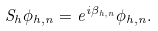<formula> <loc_0><loc_0><loc_500><loc_500>S _ { h } \phi _ { h , n } = e ^ { i \beta _ { h , n } } \phi _ { h , n } .</formula> 